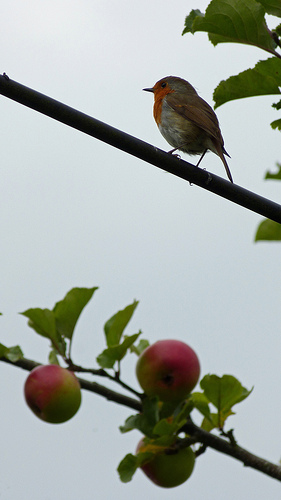What kind of bird is perched on the wire? The bird perched on the wire appears to be a European Robin, known for its distinctive orange-red breast and face. 